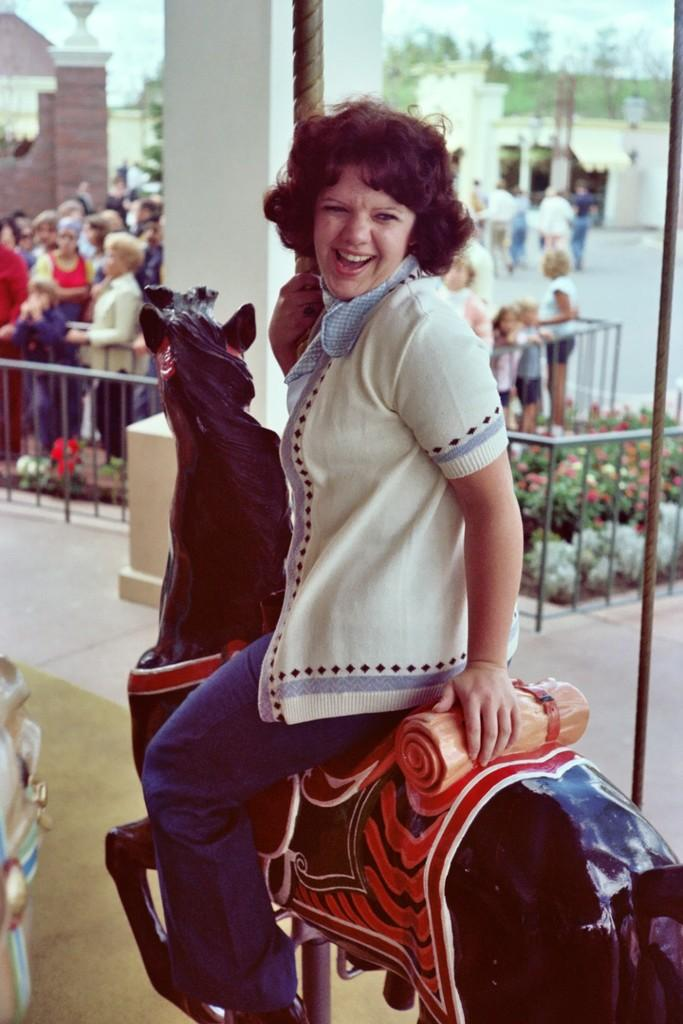What is the lady doing in the image? The lady is sitting on a horse toy in the image. What can be seen in the background of the image? There are people, bushes, trees, the sky, and a building visible in the background of the image. What type of surprise is the lady holding in her hand in the image? There is no surprise visible in the lady's hand in the image. 